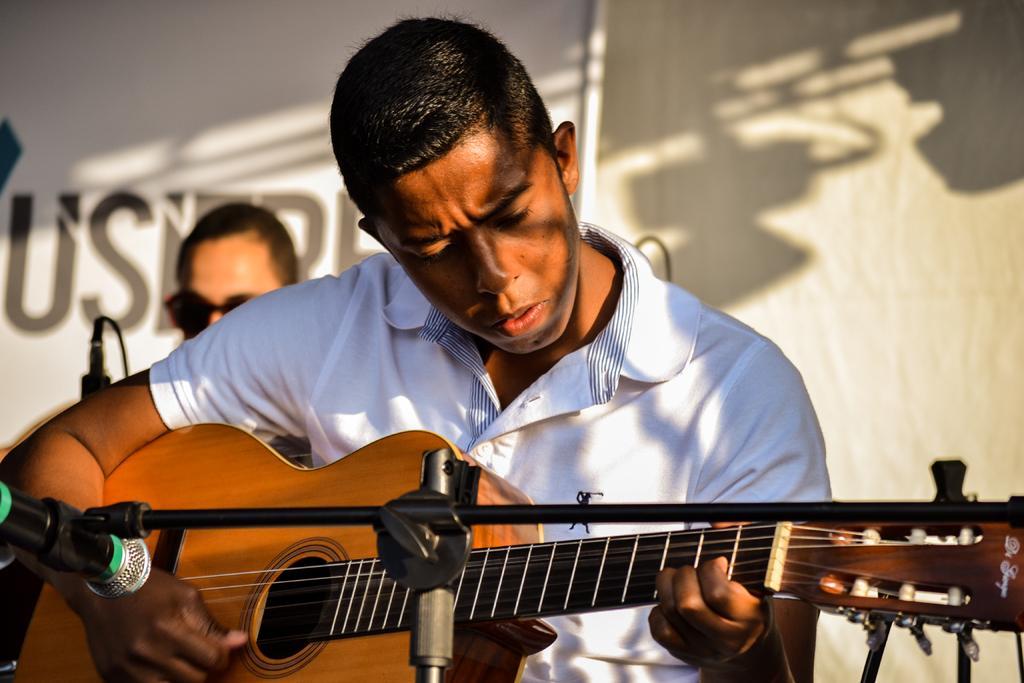Could you give a brief overview of what you see in this image? In this image in the center there is one man who is sitting and he is playing a guitar, in front of him there is one mike. On the background there is a wall, beside this person there is another person. 